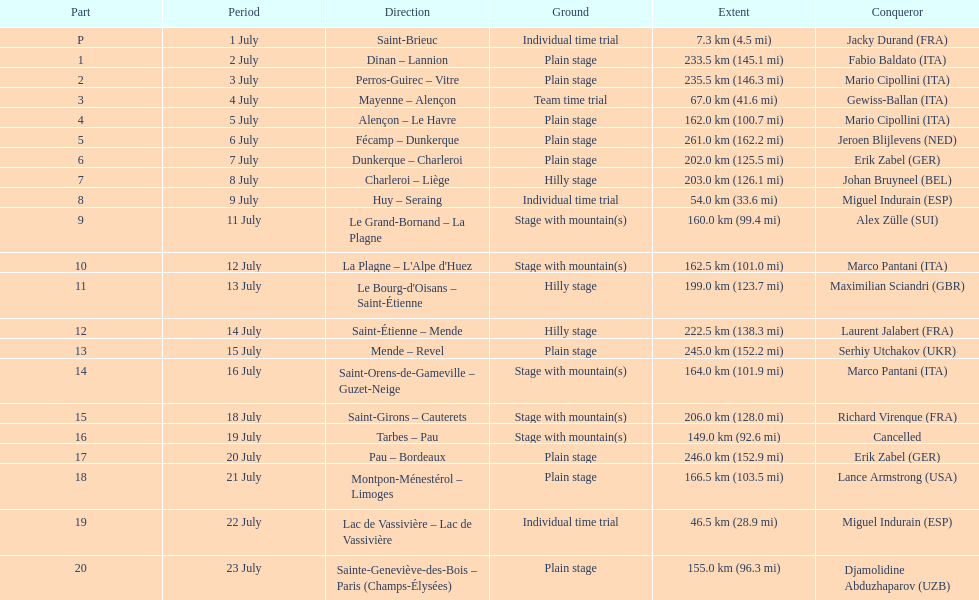How many routes have below 100 km total? 4. 